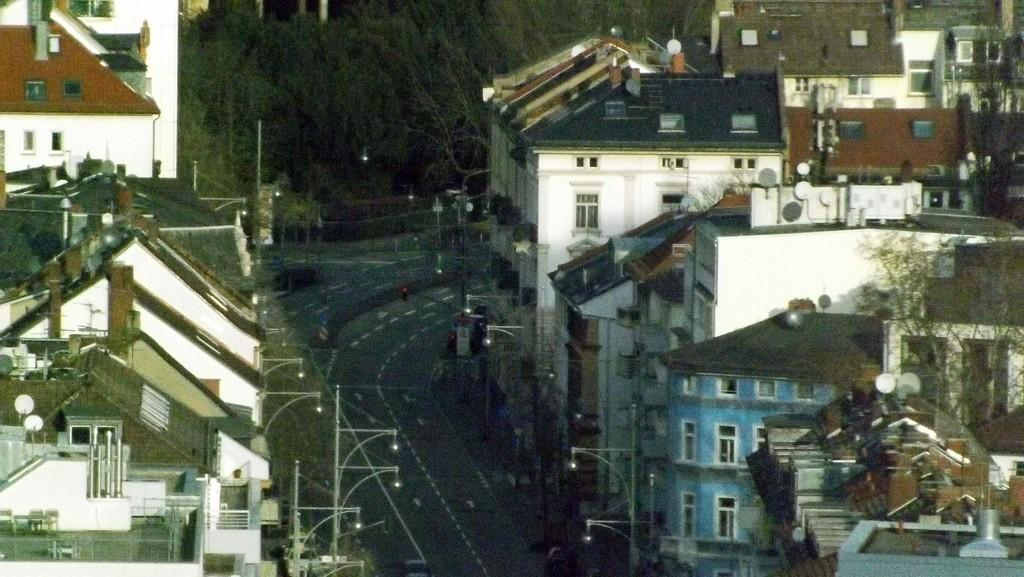What type of structures can be seen in the image? There are buildings in the image. What is installed on the buildings? Dish TVs are present on the buildings. What feature is common to all the buildings in the image? There are windows on the buildings. What are the poles in the image used for? The poles in the image are likely used for supporting cables or other infrastructure. What can be seen illuminated in the image? Lights are present in the image. What type of vegetation is visible in the image? Trees are present in the image. What type of coal is being used to fuel the son's flight in the image? There is no son or flight present in the image, and therefore no coal or fuel can be associated with them. 